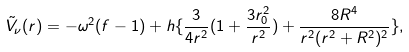Convert formula to latex. <formula><loc_0><loc_0><loc_500><loc_500>\tilde { V } _ { \nu } ( r ) = - \omega ^ { 2 } ( f - 1 ) + h \{ \frac { 3 } { 4 r ^ { 2 } } ( 1 + \frac { 3 r _ { 0 } ^ { 2 } } { r ^ { 2 } } ) + \frac { 8 R ^ { 4 } } { r ^ { 2 } ( r ^ { 2 } + R ^ { 2 } ) ^ { 2 } } \} ,</formula> 